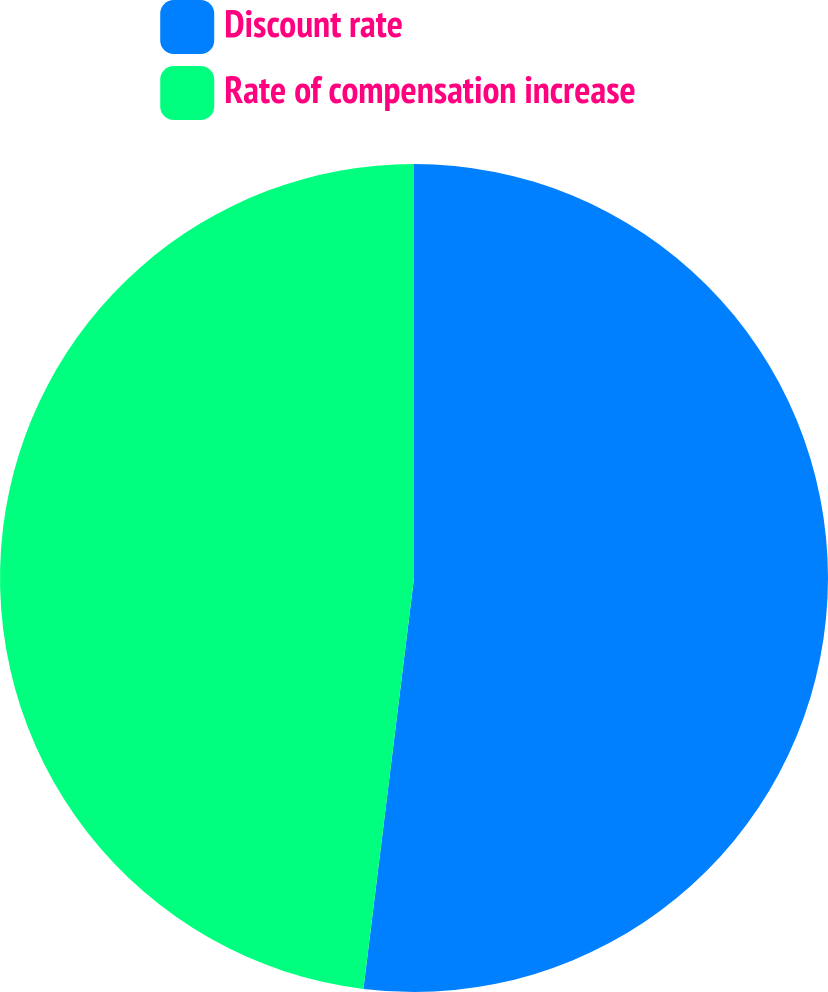Convert chart. <chart><loc_0><loc_0><loc_500><loc_500><pie_chart><fcel>Discount rate<fcel>Rate of compensation increase<nl><fcel>51.95%<fcel>48.05%<nl></chart> 